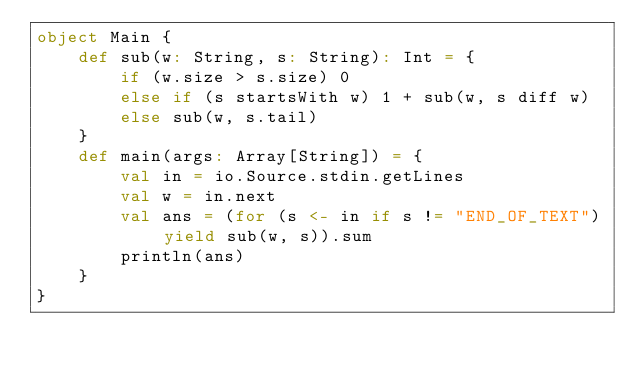Convert code to text. <code><loc_0><loc_0><loc_500><loc_500><_Scala_>object Main {
    def sub(w: String, s: String): Int = {
        if (w.size > s.size) 0
        else if (s startsWith w) 1 + sub(w, s diff w)
        else sub(w, s.tail)
    }
    def main(args: Array[String]) = {
        val in = io.Source.stdin.getLines
        val w = in.next
        val ans = (for (s <- in if s != "END_OF_TEXT") yield sub(w, s)).sum
        println(ans)
    }
}</code> 